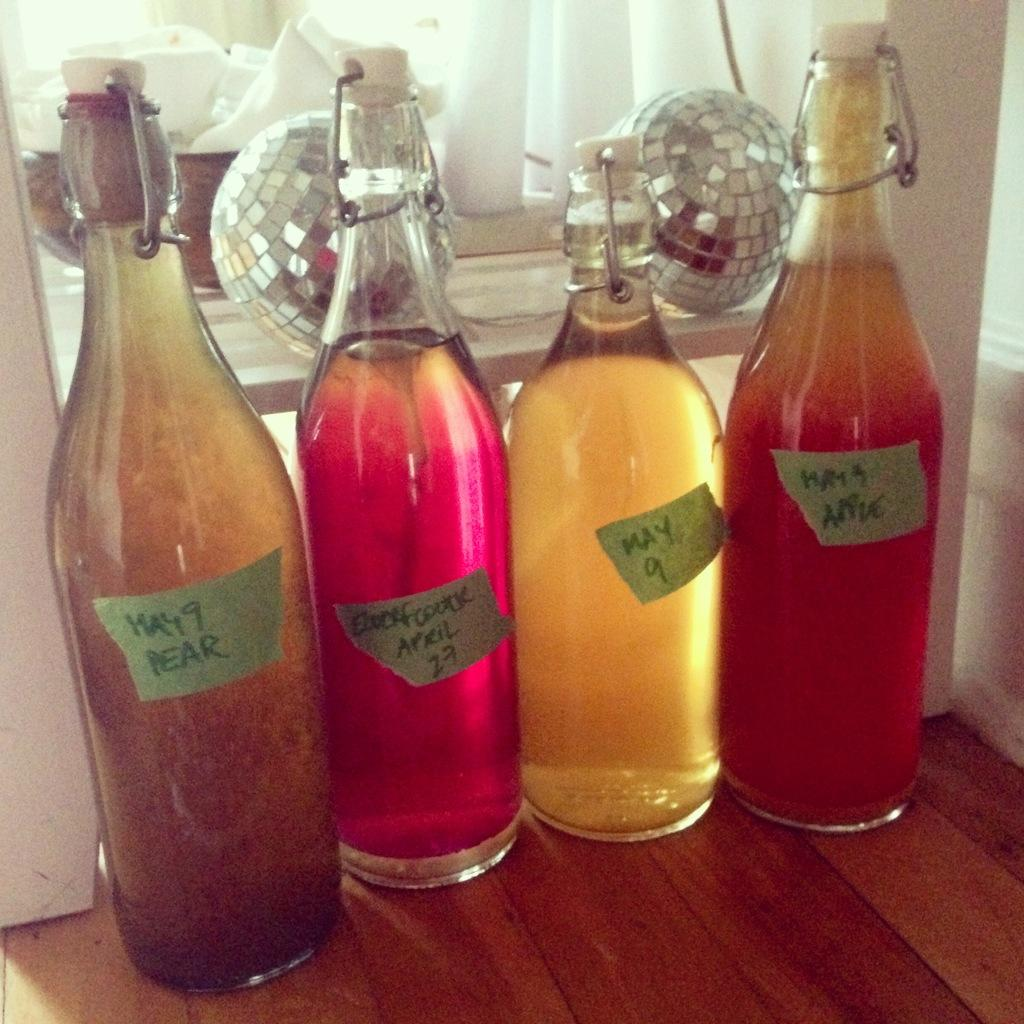How many bottles are visible in the image? There are four bottles in the image. Can you describe the location of the bowl in the image? The bowl is located in the back of the image. What language is being spoken by the bottles in the image? There is no indication that the bottles are speaking any language in the image. What details can be seen on the protest sign held by the bowl in the image? There is no protest sign or any indication of a protest in the image. 